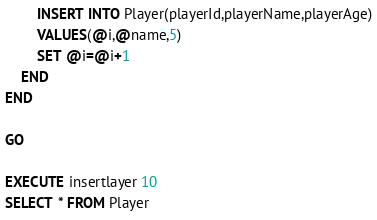Convert code to text. <code><loc_0><loc_0><loc_500><loc_500><_SQL_>		INSERT INTO Player(playerId,playerName,playerAge)
		VALUES(@i,@name,5)
		SET @i=@i+1
	END
END

GO

EXECUTE insertlayer 10
SELECT * FROM Player
</code> 